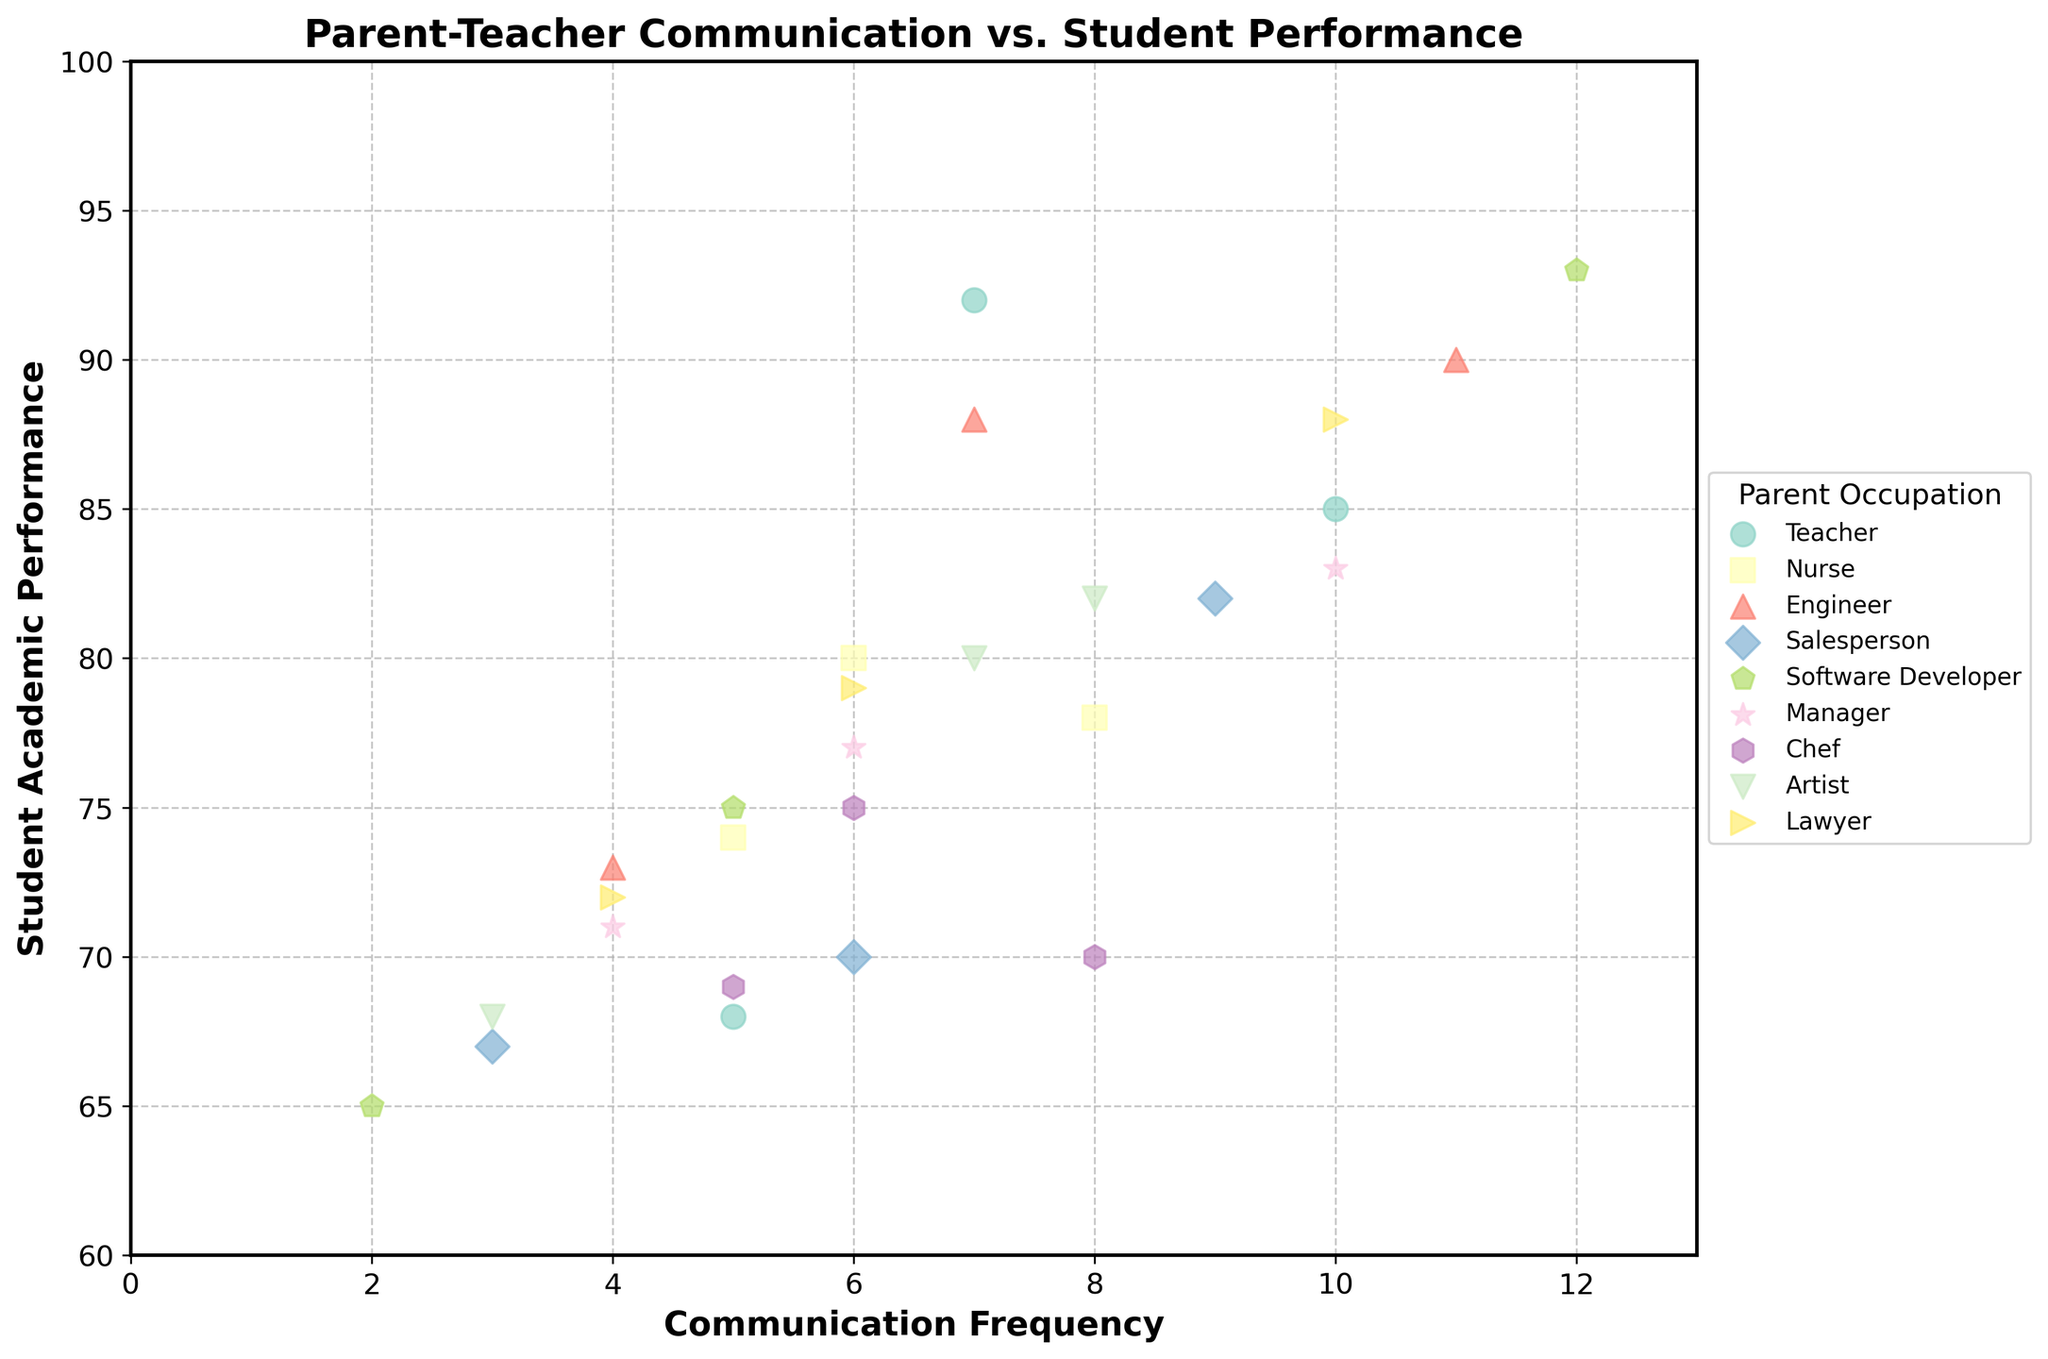What is the title of the plot? The title of the plot is displayed at the top and can be read directly from the figure.
Answer: Parent-Teacher Communication vs. Student Performance What is the color used for the data points representing Engineers? Identify the unique color associated with the 'Engineer' category by looking at the legend and matching it to the data points on the scatter plot.
Answer: (color specific to Engineers) How many data points correspond to the occupation 'Manager'? Find the 'Manager' section in the legend and count the corresponding data points in the scatter plot.
Answer: 3 What is the range of Student Academic Performance displayed in the plot? Inspect the y-axis of the plot. The lowest and highest values provide the range.
Answer: 60 to 100 Which parental occupation has the highest average Student Academic Performance? Calculate the average performance for each occupation group by summing the Academic Performance values of each group and dividing by their respective data points. Compare these averages.
Answer: Software Developer How does the Student Academic Performance vary with Communication Frequency for Lawyers compared to Nurses? Compare the data points for the 'Lawyer' and 'Nurse' groups by examining the trend or pattern indicated by their respective data points' positions on the plot.
Answer: Lawyers tend to have higher performance as communication frequency increases compared to Nurses What is the relationship between Communication Frequency and Student Academic Performance for Teachers? Look at the data points for the 'Teacher' group and identify any trend, such as an increasing or decreasing pattern, or a correlation between the two variables.
Answer: Positive relationship For which parental occupation is the variability in Student Academic Performance the highest? Calculate the range or standard deviation of Academic Performance for each occupation and identify the one with the largest spread. Detailed steps include listing the Student Academic Performance values for each occupation, finding the difference between the maximum and minimum values, and comparing these ranges.
Answer: Artist Which two occupations have similar trends in Communication Frequency vs. Student Academic Performance? Analyze the plots of different occupations to find two groups showing a similar pattern in terms of how performance changes with communication frequency.
Answer: Manager and Lawyer Is there a parental occupation where a higher Communication Frequency consistently leads to lower Student Academic Performance? Check the scatter plot groups to see if any occupation shows a negative trend where increasing communication frequency corresponds with decreasing student performance.
Answer: No 